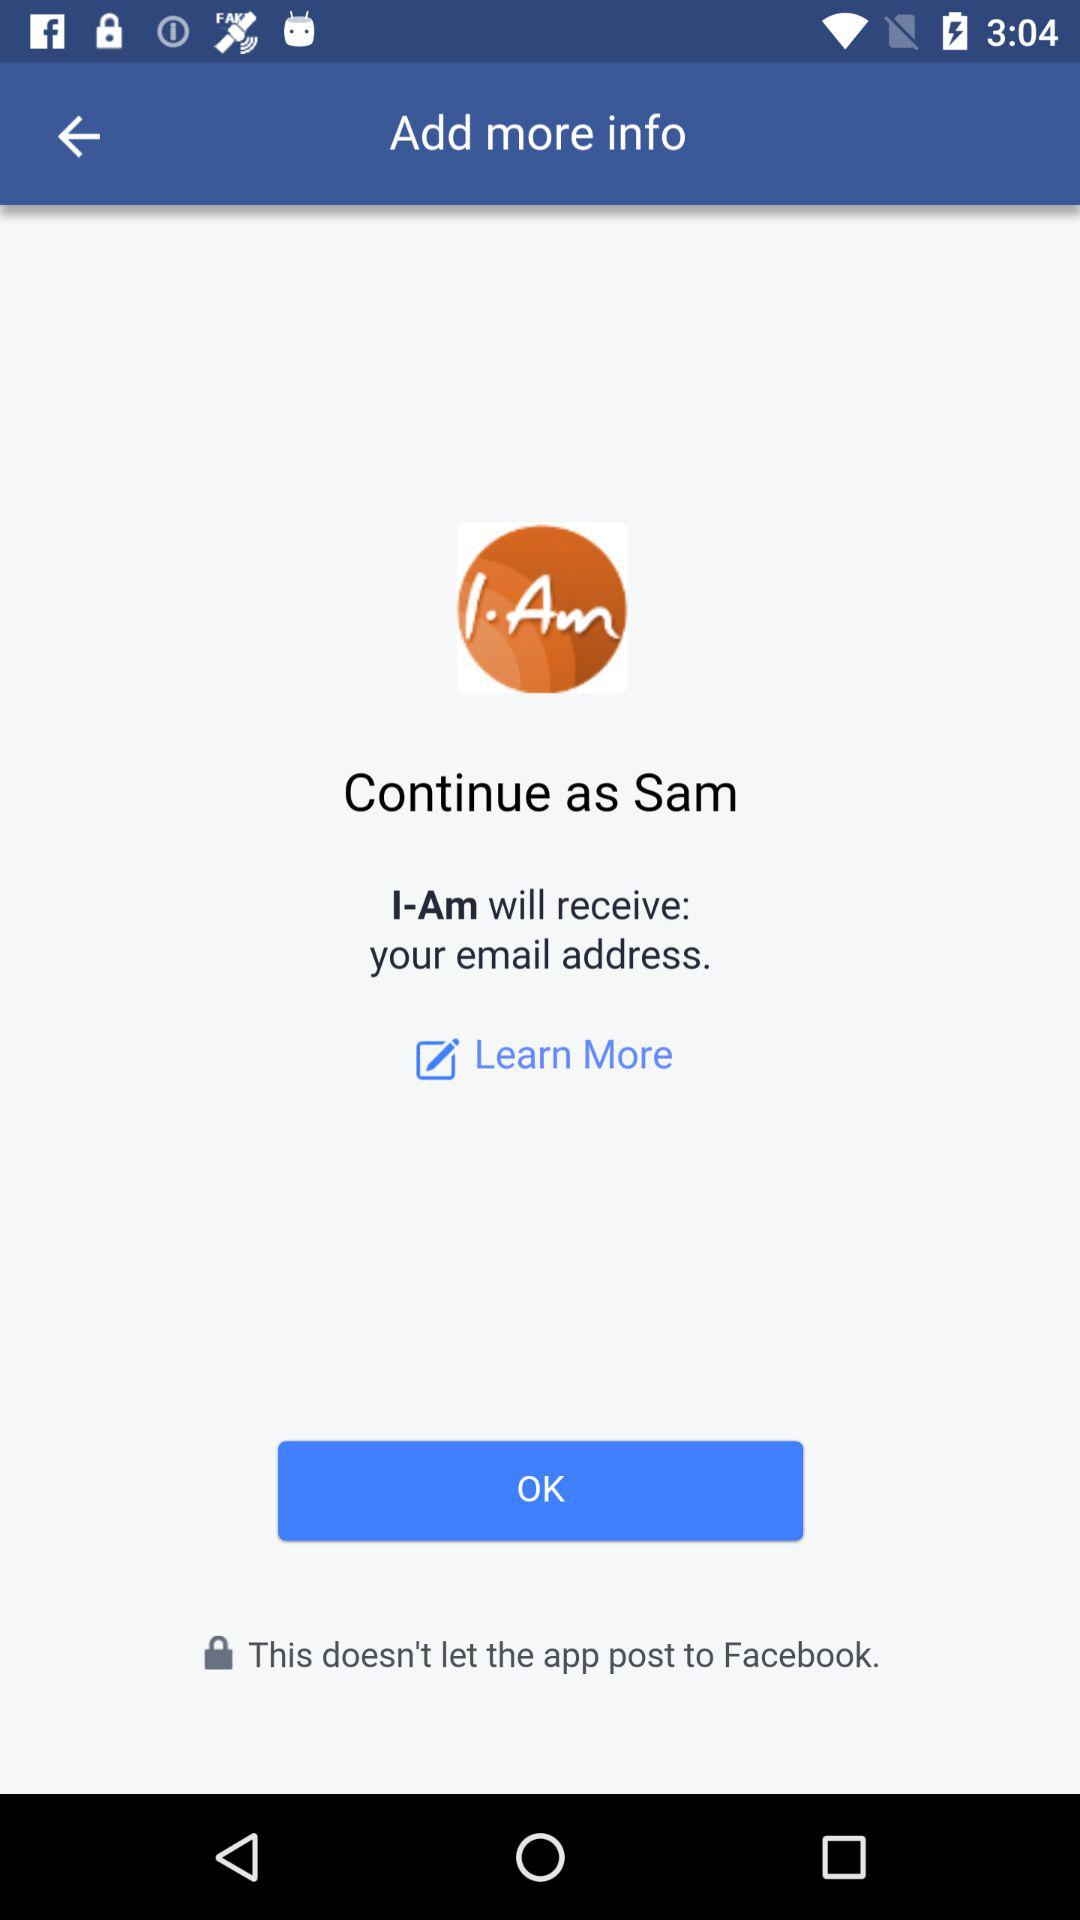Who will receive the email address? The email address will be received by "I-Am". 